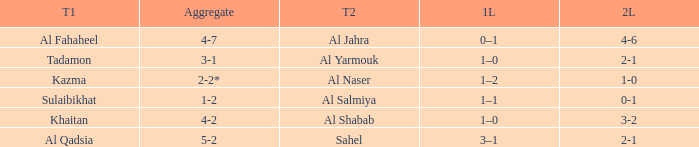What is the name of Team 2 with a Team 1 of Al Qadsia? Sahel. 